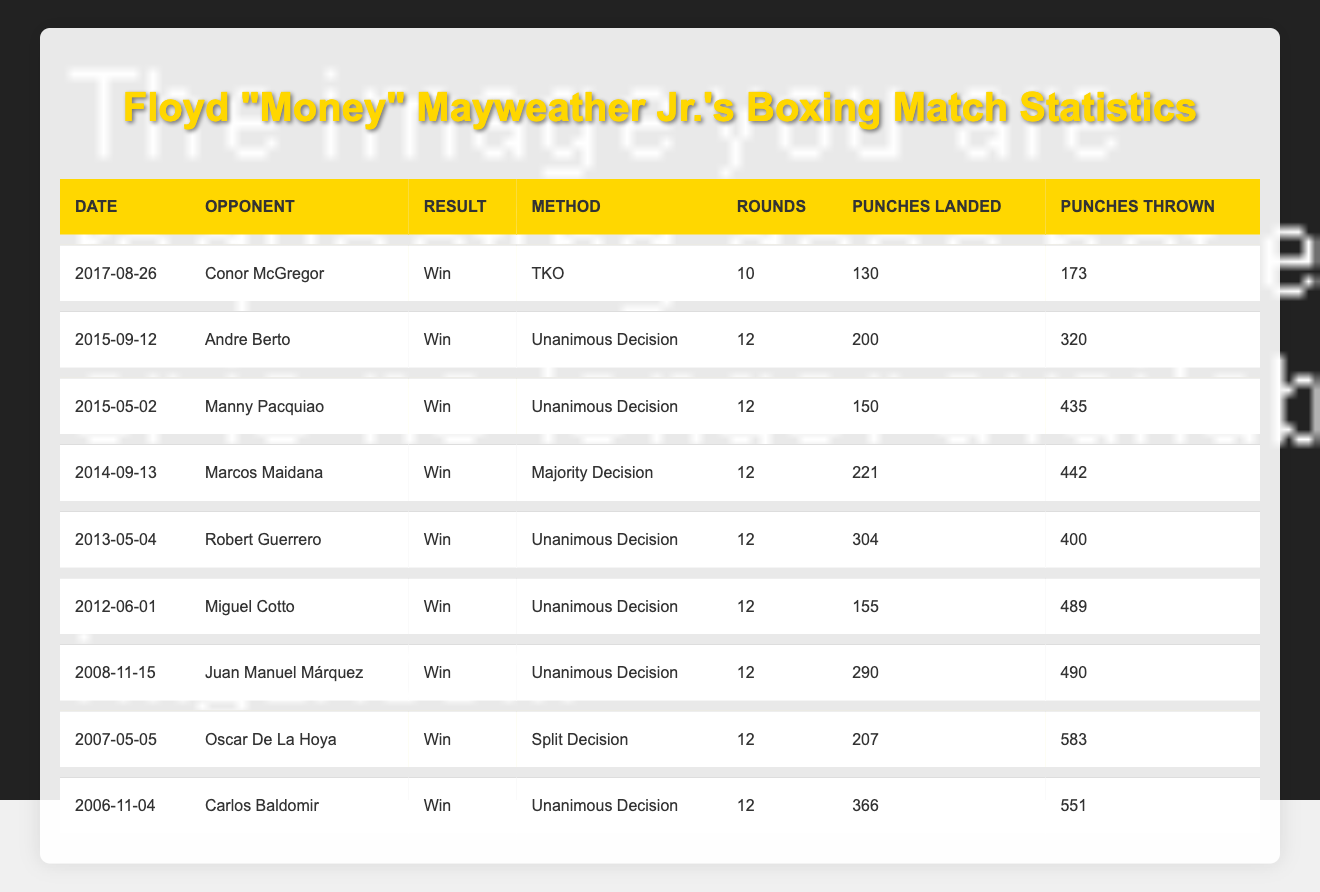What was the result of Floyd Mayweather Jr. vs. Manny Pacquiao? According to the table, Floyd Mayweather Jr. fought Manny Pacquiao on May 2, 2015, and the result was a win for Mayweather Jr.
Answer: Win How many rounds were fought in the match against Oscar De La Hoya? The table shows that the match against Oscar De La Hoya took place over 12 rounds.
Answer: 12 What is the total number of punches landed by Floyd Mayweather Jr. in the fight against Robert Guerrero? Referring to the table, the total punches landed by Mayweather Jr. against Robert Guerrero was 304.
Answer: 304 How many total punches were thrown in the fight against Carlos Baldomir? In the table, it is noted that a total of 551 punches were thrown in the fight against Carlos Baldomir.
Answer: 551 Which opponent had the highest number of punches thrown against Floyd Mayweather Jr.? Looking at the table, Oscar De La Hoya had the highest punches thrown against Mayweather Jr., totaling 583.
Answer: Oscar De La Hoya What was Floyd Mayweather Jr.'s punching accuracy in the fight against Andre Berto? To find the accuracy, divide punches landed (200) by punches thrown (320), then multiply by 100. The calculation is (200/320) * 100 = 62.5%.
Answer: 62.5% Did Floyd Mayweather Jr. win every match displayed in the table? The table indicates that Floyd Mayweather Jr. won all the matches listed, meaning the answer is yes.
Answer: Yes What was the average number of rounds fought in Mayweather Jr.'s recorded matches? There are 8 matches, each consisting of 12 rounds except for the fight against Conor McGregor, which had 10 rounds. The total rounds sum up to (7 * 12) + 10 = 94, and the average is 94/8 = 11.75.
Answer: 11.75 Which opponent did Floyd Mayweather Jr. defeat by TKO, and how many rounds did that fight last? The fight against Conor McGregor resulted in a TKO win for Mayweather Jr. after 10 rounds.
Answer: Conor McGregor, 10 rounds How many punches did Floyd Mayweather Jr. land in his match against Miguel Cotto, and was it more than in the fight against Juan Manuel Márquez? From the table, Mayweather Jr. landed 155 punches against Miguel Cotto and 290 against Juan Manuel Márquez. Since 155 is less than 290, the answer is no.
Answer: No 